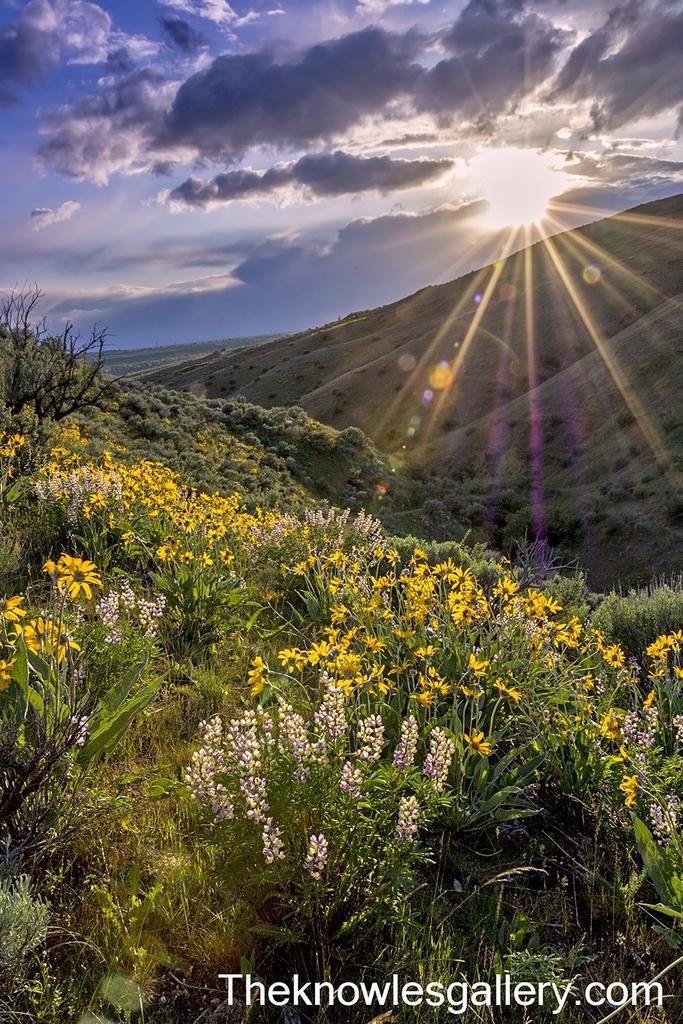Please provide a concise description of this image. In this picture we can see few plants, flowers, trees and hills, in the background we can see clouds and the sun, in the bottom right hand corner we can see some text. 